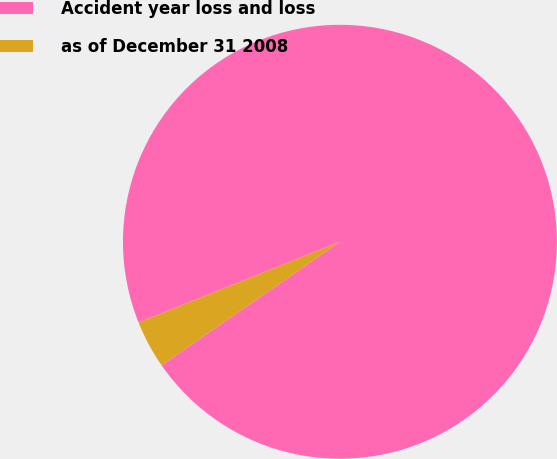<chart> <loc_0><loc_0><loc_500><loc_500><pie_chart><fcel>Accident year loss and loss<fcel>as of December 31 2008<nl><fcel>96.43%<fcel>3.57%<nl></chart> 